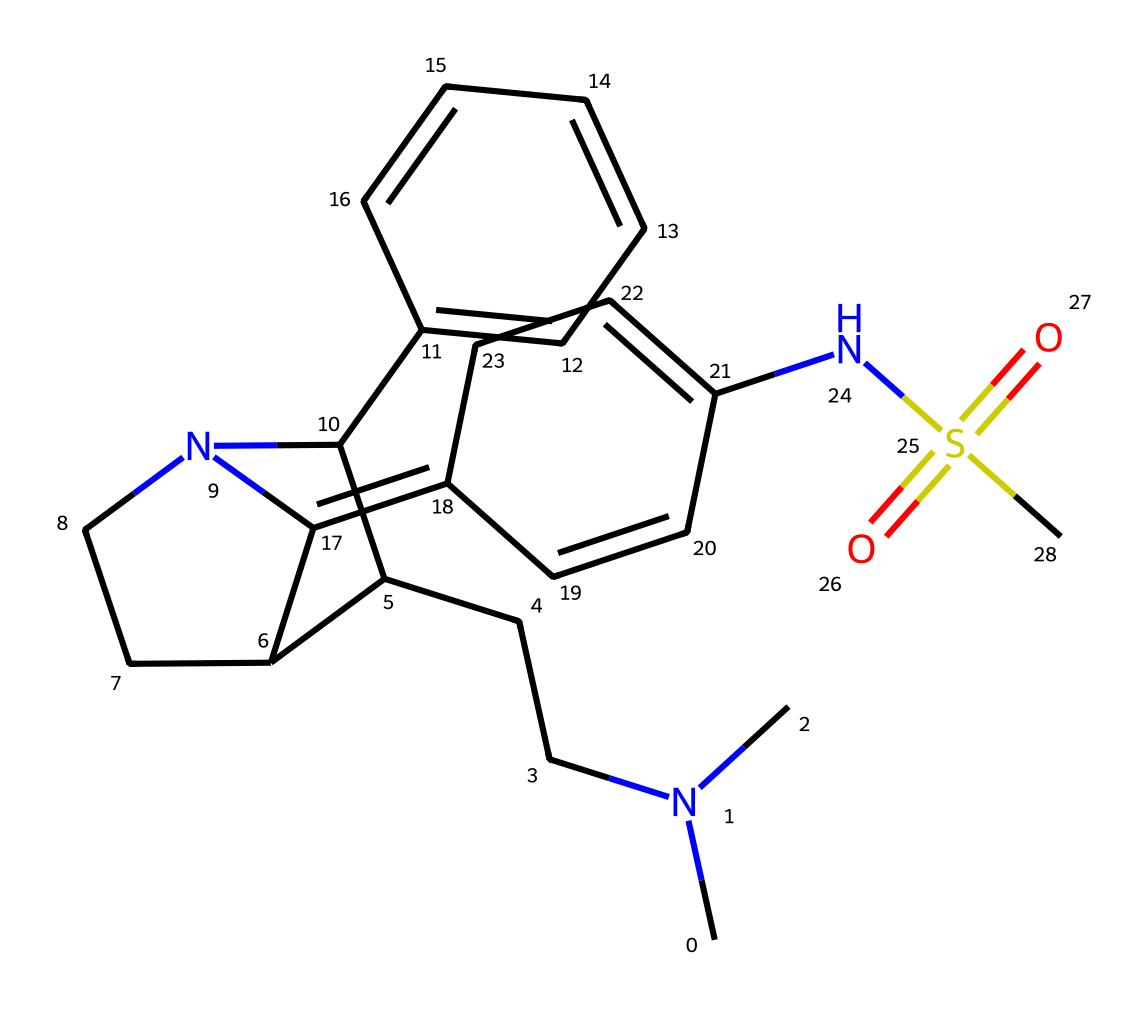What is the molecular formula of this compound? To obtain the molecular formula, we need to count the different atoms in the SMILES representation. The SMILES indicates the presence of carbon (C), nitrogen (N), sulfur (S), and oxygen (O) atoms. Counting gives us C17, H21, N3, O2, and S. So, the molecular formula is constructed by identifying the count of each atom type present.
Answer: C17H21N3O2S How many nitrogen atoms are present in this molecule? Examining the SMILES structure, we can identify nitrogen by looking for 'N'. There are three nitrogen atoms present in the overall molecular structure.
Answer: 3 What type of functional group is indicated by the presence of the -SO2- moiety in the molecule? The -SO2- moiety denotes a sulfonamide functional group. This can be identified by recognizing the sulfur bonded to two oxygen atoms and it typically indicates sulfonamide or sulfonic acid functionality.
Answer: sulfonamide What is the stereochemistry indicator present in the molecule? Stereochemistry in the SMILES can be inferred from the presence of explicitly defined ring structures and their connectivity. Additionally, the presence of chiral centers can be indicated by the utilization of specific architecture in the SMILES code, though no stereochemistry indicators like '[@]' are present in the provided SMILES, it indicates simplified representation rather than an absolute stereochemistry.
Answer: none Which component of the structure suggests it's a member of the triptan family? The presence of the indole-like structure, indicated by the bicyclic system with a nitrogen atom in the ring, is characteristic of triptans. This structural feature is crucial for its pharmacological activity.
Answer: indole-like structure What type of chemical is sumatriptan classified as? Sumatriptan is classified as a triptan, which is a type of medication specifically used for treating migraines. The classification is based on the overall pharmacophore model that includes the indole core linked with a sulfonamide group.
Answer: triptan 